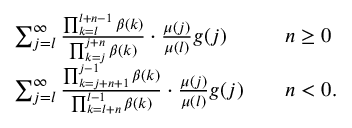<formula> <loc_0><loc_0><loc_500><loc_500>\begin{array} { r l r l } & { \sum _ { j = l } ^ { \infty } \frac { \prod _ { k = l } ^ { l + n - 1 } \beta ( k ) } { \prod _ { k = j } ^ { j + n } \beta ( k ) } \cdot \frac { \mu ( j ) } { \mu ( l ) } g ( j ) } & & { n \geq 0 } \\ & { \sum _ { j = l } ^ { \infty } \frac { \prod _ { k = j + n + 1 } ^ { j - 1 } \beta ( k ) } { \prod _ { k = l + n } ^ { l - 1 } \beta ( k ) } \cdot \frac { \mu ( j ) } { \mu ( l ) } g ( j ) } & & { n < 0 . } \end{array}</formula> 